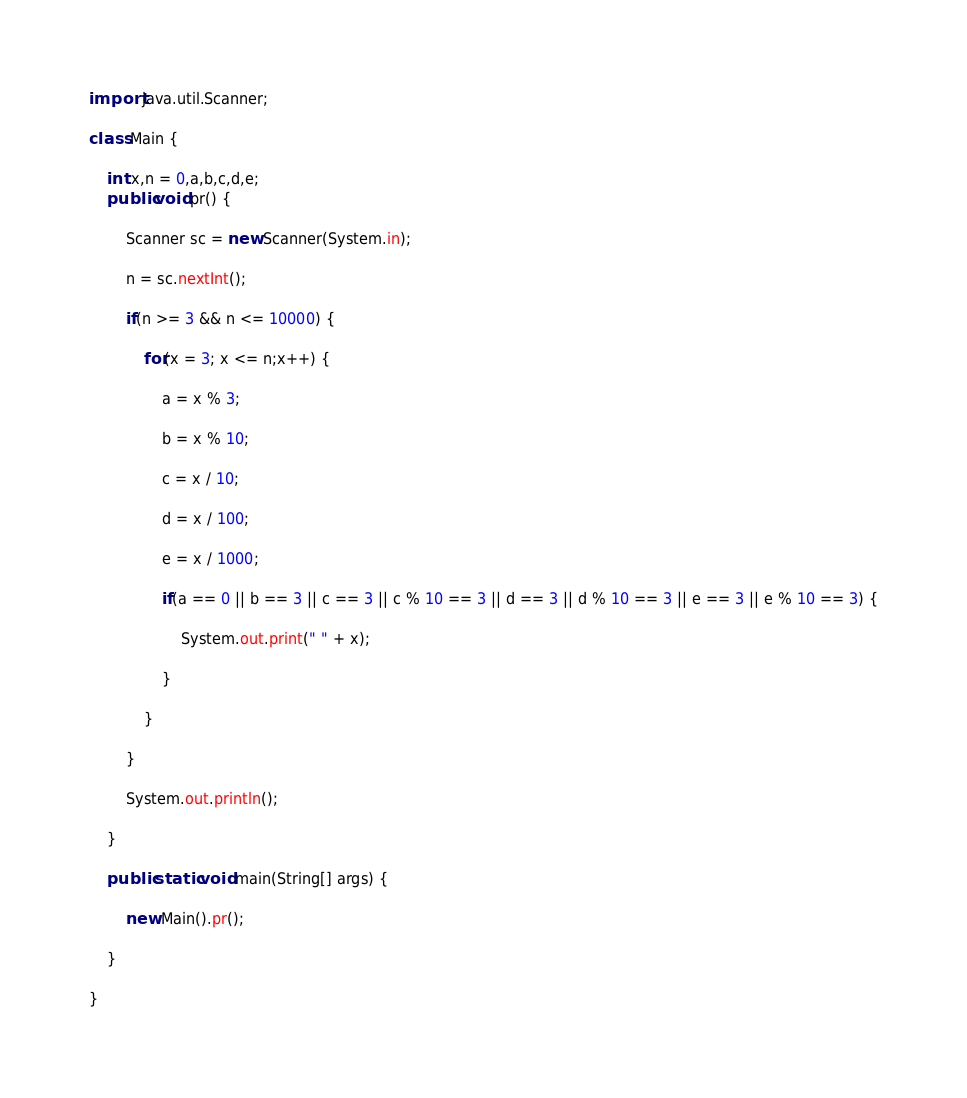Convert code to text. <code><loc_0><loc_0><loc_500><loc_500><_Java_>import java.util.Scanner;

class Main {

	int x,n = 0,a,b,c,d,e;
	public void pr() {

		Scanner sc = new Scanner(System.in);

		n = sc.nextInt();

		if(n >= 3 && n <= 10000) {

			for(x = 3; x <= n;x++) {

				a = x % 3;

				b = x % 10;

				c = x / 10;

				d = x / 100;

				e = x / 1000;

				if(a == 0 || b == 3 || c == 3 || c % 10 == 3 || d == 3 || d % 10 == 3 || e == 3 || e % 10 == 3) {

					System.out.print(" " + x);

				}

			}

		}

		System.out.println();

	}

	public static void main(String[] args) {

		new Main().pr();

	}

}</code> 